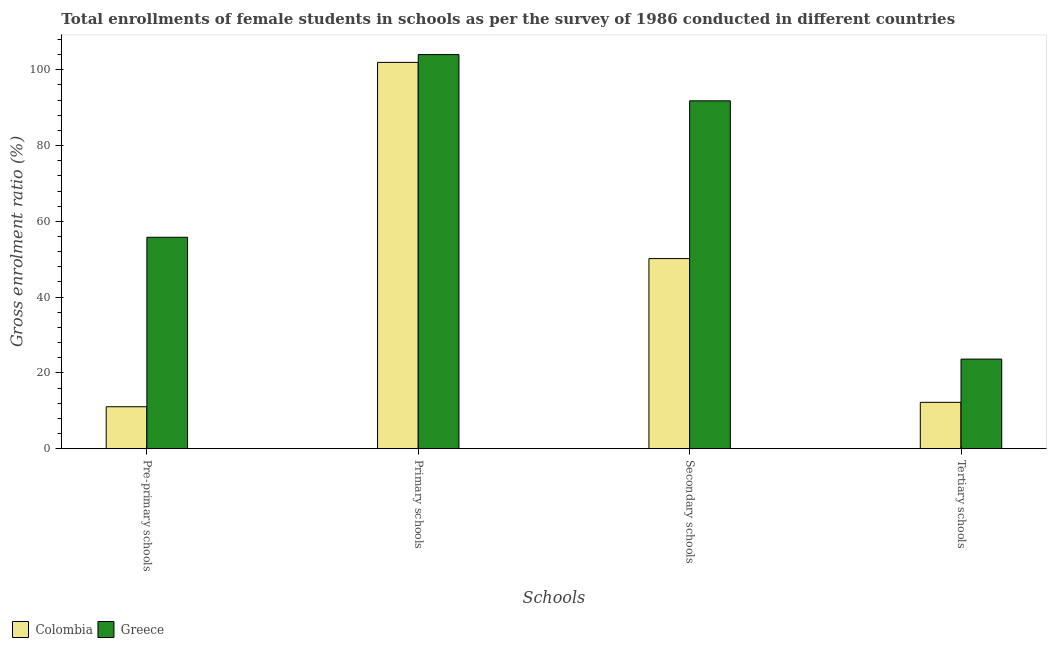How many groups of bars are there?
Your response must be concise. 4. Are the number of bars per tick equal to the number of legend labels?
Keep it short and to the point. Yes. How many bars are there on the 3rd tick from the left?
Offer a very short reply. 2. How many bars are there on the 1st tick from the right?
Ensure brevity in your answer.  2. What is the label of the 3rd group of bars from the left?
Your response must be concise. Secondary schools. What is the gross enrolment ratio(female) in tertiary schools in Greece?
Ensure brevity in your answer.  23.64. Across all countries, what is the maximum gross enrolment ratio(female) in secondary schools?
Your answer should be very brief. 91.81. Across all countries, what is the minimum gross enrolment ratio(female) in pre-primary schools?
Give a very brief answer. 11.07. In which country was the gross enrolment ratio(female) in tertiary schools maximum?
Ensure brevity in your answer.  Greece. What is the total gross enrolment ratio(female) in tertiary schools in the graph?
Your answer should be compact. 35.88. What is the difference between the gross enrolment ratio(female) in secondary schools in Greece and that in Colombia?
Provide a short and direct response. 41.64. What is the difference between the gross enrolment ratio(female) in pre-primary schools in Greece and the gross enrolment ratio(female) in tertiary schools in Colombia?
Ensure brevity in your answer.  43.57. What is the average gross enrolment ratio(female) in primary schools per country?
Offer a very short reply. 102.99. What is the difference between the gross enrolment ratio(female) in primary schools and gross enrolment ratio(female) in secondary schools in Colombia?
Offer a terse response. 51.79. In how many countries, is the gross enrolment ratio(female) in primary schools greater than 96 %?
Provide a short and direct response. 2. What is the ratio of the gross enrolment ratio(female) in primary schools in Greece to that in Colombia?
Make the answer very short. 1.02. What is the difference between the highest and the second highest gross enrolment ratio(female) in secondary schools?
Keep it short and to the point. 41.64. What is the difference between the highest and the lowest gross enrolment ratio(female) in tertiary schools?
Give a very brief answer. 11.41. Is the sum of the gross enrolment ratio(female) in secondary schools in Greece and Colombia greater than the maximum gross enrolment ratio(female) in pre-primary schools across all countries?
Make the answer very short. Yes. Is it the case that in every country, the sum of the gross enrolment ratio(female) in secondary schools and gross enrolment ratio(female) in pre-primary schools is greater than the sum of gross enrolment ratio(female) in tertiary schools and gross enrolment ratio(female) in primary schools?
Your response must be concise. Yes. Is it the case that in every country, the sum of the gross enrolment ratio(female) in pre-primary schools and gross enrolment ratio(female) in primary schools is greater than the gross enrolment ratio(female) in secondary schools?
Give a very brief answer. Yes. How many bars are there?
Your answer should be compact. 8. Are all the bars in the graph horizontal?
Your answer should be compact. No. Does the graph contain grids?
Your response must be concise. No. Where does the legend appear in the graph?
Ensure brevity in your answer.  Bottom left. How many legend labels are there?
Ensure brevity in your answer.  2. What is the title of the graph?
Give a very brief answer. Total enrollments of female students in schools as per the survey of 1986 conducted in different countries. Does "Nepal" appear as one of the legend labels in the graph?
Your answer should be compact. No. What is the label or title of the X-axis?
Provide a short and direct response. Schools. What is the label or title of the Y-axis?
Provide a succinct answer. Gross enrolment ratio (%). What is the Gross enrolment ratio (%) in Colombia in Pre-primary schools?
Provide a short and direct response. 11.07. What is the Gross enrolment ratio (%) in Greece in Pre-primary schools?
Your answer should be compact. 55.8. What is the Gross enrolment ratio (%) in Colombia in Primary schools?
Provide a short and direct response. 101.96. What is the Gross enrolment ratio (%) of Greece in Primary schools?
Ensure brevity in your answer.  104.02. What is the Gross enrolment ratio (%) in Colombia in Secondary schools?
Give a very brief answer. 50.17. What is the Gross enrolment ratio (%) in Greece in Secondary schools?
Give a very brief answer. 91.81. What is the Gross enrolment ratio (%) of Colombia in Tertiary schools?
Provide a short and direct response. 12.23. What is the Gross enrolment ratio (%) in Greece in Tertiary schools?
Provide a succinct answer. 23.64. Across all Schools, what is the maximum Gross enrolment ratio (%) in Colombia?
Offer a terse response. 101.96. Across all Schools, what is the maximum Gross enrolment ratio (%) in Greece?
Your answer should be compact. 104.02. Across all Schools, what is the minimum Gross enrolment ratio (%) of Colombia?
Ensure brevity in your answer.  11.07. Across all Schools, what is the minimum Gross enrolment ratio (%) of Greece?
Make the answer very short. 23.64. What is the total Gross enrolment ratio (%) in Colombia in the graph?
Provide a succinct answer. 175.44. What is the total Gross enrolment ratio (%) of Greece in the graph?
Make the answer very short. 275.28. What is the difference between the Gross enrolment ratio (%) in Colombia in Pre-primary schools and that in Primary schools?
Your answer should be very brief. -90.89. What is the difference between the Gross enrolment ratio (%) in Greece in Pre-primary schools and that in Primary schools?
Keep it short and to the point. -48.22. What is the difference between the Gross enrolment ratio (%) in Colombia in Pre-primary schools and that in Secondary schools?
Ensure brevity in your answer.  -39.11. What is the difference between the Gross enrolment ratio (%) in Greece in Pre-primary schools and that in Secondary schools?
Your answer should be very brief. -36.01. What is the difference between the Gross enrolment ratio (%) of Colombia in Pre-primary schools and that in Tertiary schools?
Your response must be concise. -1.17. What is the difference between the Gross enrolment ratio (%) of Greece in Pre-primary schools and that in Tertiary schools?
Your answer should be compact. 32.16. What is the difference between the Gross enrolment ratio (%) in Colombia in Primary schools and that in Secondary schools?
Provide a short and direct response. 51.79. What is the difference between the Gross enrolment ratio (%) in Greece in Primary schools and that in Secondary schools?
Provide a short and direct response. 12.21. What is the difference between the Gross enrolment ratio (%) of Colombia in Primary schools and that in Tertiary schools?
Offer a terse response. 89.73. What is the difference between the Gross enrolment ratio (%) of Greece in Primary schools and that in Tertiary schools?
Your answer should be very brief. 80.38. What is the difference between the Gross enrolment ratio (%) in Colombia in Secondary schools and that in Tertiary schools?
Give a very brief answer. 37.94. What is the difference between the Gross enrolment ratio (%) in Greece in Secondary schools and that in Tertiary schools?
Ensure brevity in your answer.  68.17. What is the difference between the Gross enrolment ratio (%) of Colombia in Pre-primary schools and the Gross enrolment ratio (%) of Greece in Primary schools?
Provide a short and direct response. -92.95. What is the difference between the Gross enrolment ratio (%) in Colombia in Pre-primary schools and the Gross enrolment ratio (%) in Greece in Secondary schools?
Give a very brief answer. -80.75. What is the difference between the Gross enrolment ratio (%) in Colombia in Pre-primary schools and the Gross enrolment ratio (%) in Greece in Tertiary schools?
Keep it short and to the point. -12.58. What is the difference between the Gross enrolment ratio (%) in Colombia in Primary schools and the Gross enrolment ratio (%) in Greece in Secondary schools?
Your answer should be very brief. 10.15. What is the difference between the Gross enrolment ratio (%) of Colombia in Primary schools and the Gross enrolment ratio (%) of Greece in Tertiary schools?
Keep it short and to the point. 78.32. What is the difference between the Gross enrolment ratio (%) of Colombia in Secondary schools and the Gross enrolment ratio (%) of Greece in Tertiary schools?
Offer a terse response. 26.53. What is the average Gross enrolment ratio (%) of Colombia per Schools?
Provide a succinct answer. 43.86. What is the average Gross enrolment ratio (%) of Greece per Schools?
Your response must be concise. 68.82. What is the difference between the Gross enrolment ratio (%) in Colombia and Gross enrolment ratio (%) in Greece in Pre-primary schools?
Provide a succinct answer. -44.73. What is the difference between the Gross enrolment ratio (%) in Colombia and Gross enrolment ratio (%) in Greece in Primary schools?
Keep it short and to the point. -2.06. What is the difference between the Gross enrolment ratio (%) in Colombia and Gross enrolment ratio (%) in Greece in Secondary schools?
Ensure brevity in your answer.  -41.64. What is the difference between the Gross enrolment ratio (%) in Colombia and Gross enrolment ratio (%) in Greece in Tertiary schools?
Ensure brevity in your answer.  -11.41. What is the ratio of the Gross enrolment ratio (%) in Colombia in Pre-primary schools to that in Primary schools?
Provide a short and direct response. 0.11. What is the ratio of the Gross enrolment ratio (%) in Greece in Pre-primary schools to that in Primary schools?
Provide a short and direct response. 0.54. What is the ratio of the Gross enrolment ratio (%) in Colombia in Pre-primary schools to that in Secondary schools?
Provide a short and direct response. 0.22. What is the ratio of the Gross enrolment ratio (%) in Greece in Pre-primary schools to that in Secondary schools?
Offer a very short reply. 0.61. What is the ratio of the Gross enrolment ratio (%) of Colombia in Pre-primary schools to that in Tertiary schools?
Your response must be concise. 0.9. What is the ratio of the Gross enrolment ratio (%) in Greece in Pre-primary schools to that in Tertiary schools?
Provide a succinct answer. 2.36. What is the ratio of the Gross enrolment ratio (%) in Colombia in Primary schools to that in Secondary schools?
Provide a short and direct response. 2.03. What is the ratio of the Gross enrolment ratio (%) in Greece in Primary schools to that in Secondary schools?
Provide a succinct answer. 1.13. What is the ratio of the Gross enrolment ratio (%) of Colombia in Primary schools to that in Tertiary schools?
Your answer should be compact. 8.34. What is the ratio of the Gross enrolment ratio (%) in Greece in Primary schools to that in Tertiary schools?
Give a very brief answer. 4.4. What is the ratio of the Gross enrolment ratio (%) of Colombia in Secondary schools to that in Tertiary schools?
Your response must be concise. 4.1. What is the ratio of the Gross enrolment ratio (%) of Greece in Secondary schools to that in Tertiary schools?
Make the answer very short. 3.88. What is the difference between the highest and the second highest Gross enrolment ratio (%) in Colombia?
Offer a terse response. 51.79. What is the difference between the highest and the second highest Gross enrolment ratio (%) in Greece?
Keep it short and to the point. 12.21. What is the difference between the highest and the lowest Gross enrolment ratio (%) in Colombia?
Offer a very short reply. 90.89. What is the difference between the highest and the lowest Gross enrolment ratio (%) in Greece?
Your answer should be compact. 80.38. 